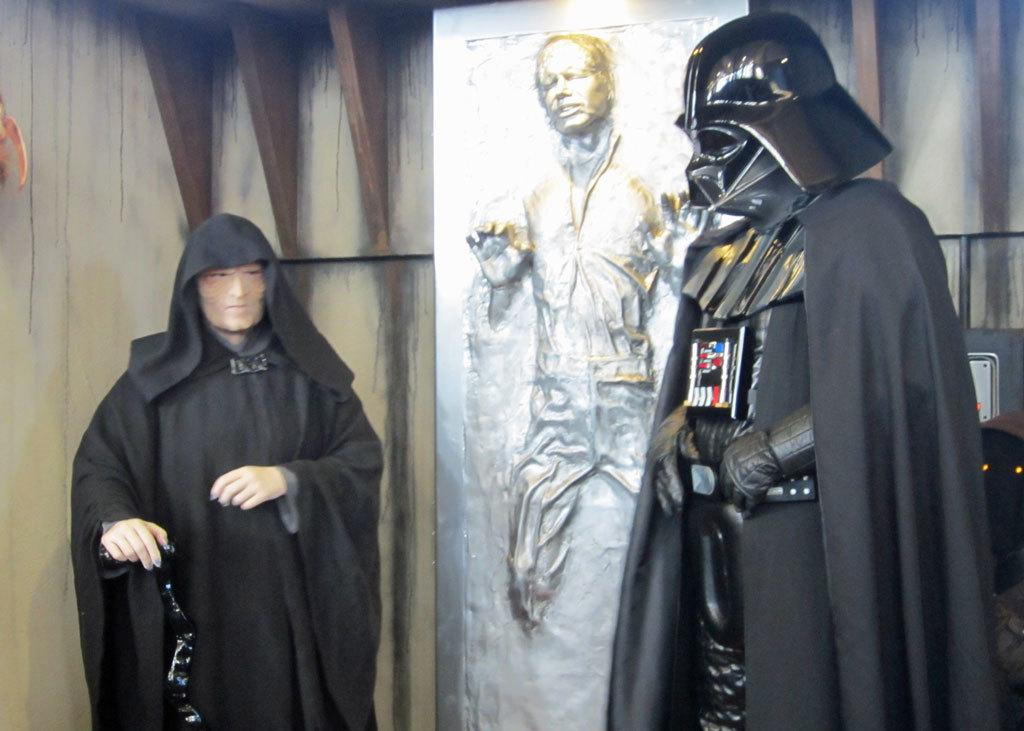What can be seen in the image? There are statues in the image. What is visible in the background of the image? There is a wall in the background of the image. What committee is responsible for the statues in the image? There is no information about a committee in the image or the facts provided. 